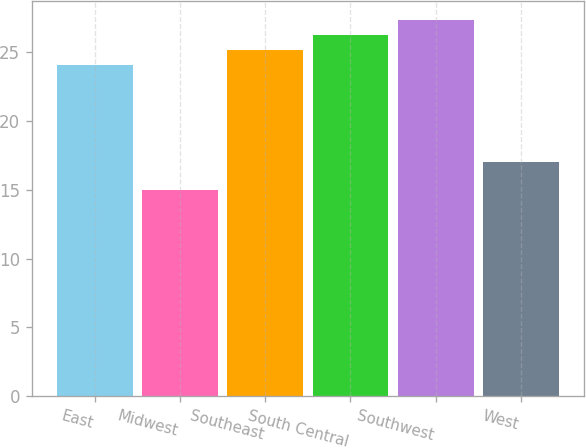Convert chart to OTSL. <chart><loc_0><loc_0><loc_500><loc_500><bar_chart><fcel>East<fcel>Midwest<fcel>Southeast<fcel>South Central<fcel>Southwest<fcel>West<nl><fcel>24<fcel>15<fcel>25.1<fcel>26.2<fcel>27.3<fcel>17<nl></chart> 